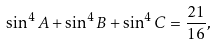<formula> <loc_0><loc_0><loc_500><loc_500>\sin ^ { 4 } A + \sin ^ { 4 } B + \sin ^ { 4 } C = { \frac { 2 1 } { 1 6 } } ,</formula> 